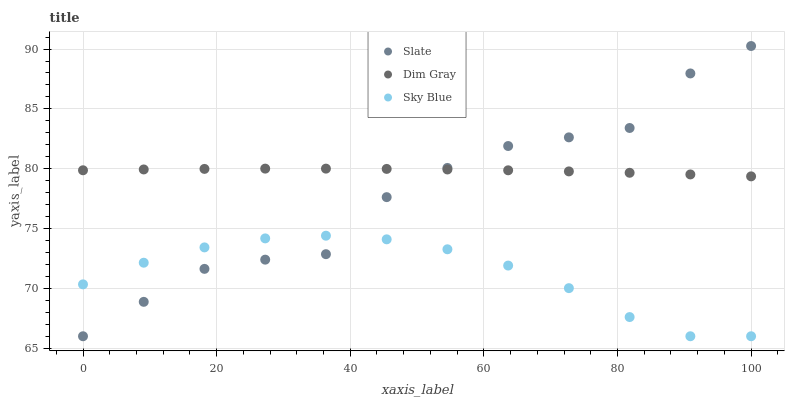Does Sky Blue have the minimum area under the curve?
Answer yes or no. Yes. Does Dim Gray have the maximum area under the curve?
Answer yes or no. Yes. Does Slate have the minimum area under the curve?
Answer yes or no. No. Does Slate have the maximum area under the curve?
Answer yes or no. No. Is Dim Gray the smoothest?
Answer yes or no. Yes. Is Slate the roughest?
Answer yes or no. Yes. Is Slate the smoothest?
Answer yes or no. No. Is Dim Gray the roughest?
Answer yes or no. No. Does Sky Blue have the lowest value?
Answer yes or no. Yes. Does Dim Gray have the lowest value?
Answer yes or no. No. Does Slate have the highest value?
Answer yes or no. Yes. Does Dim Gray have the highest value?
Answer yes or no. No. Is Sky Blue less than Dim Gray?
Answer yes or no. Yes. Is Dim Gray greater than Sky Blue?
Answer yes or no. Yes. Does Slate intersect Sky Blue?
Answer yes or no. Yes. Is Slate less than Sky Blue?
Answer yes or no. No. Is Slate greater than Sky Blue?
Answer yes or no. No. Does Sky Blue intersect Dim Gray?
Answer yes or no. No. 